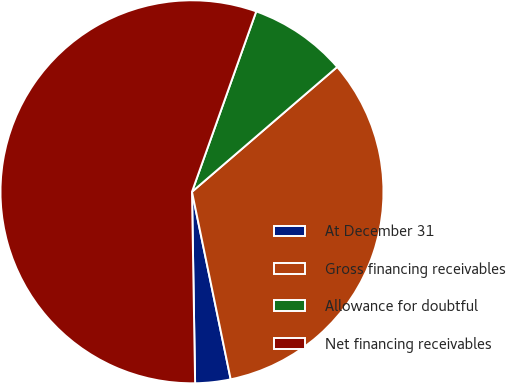Convert chart. <chart><loc_0><loc_0><loc_500><loc_500><pie_chart><fcel>At December 31<fcel>Gross financing receivables<fcel>Allowance for doubtful<fcel>Net financing receivables<nl><fcel>2.98%<fcel>33.06%<fcel>8.25%<fcel>55.7%<nl></chart> 